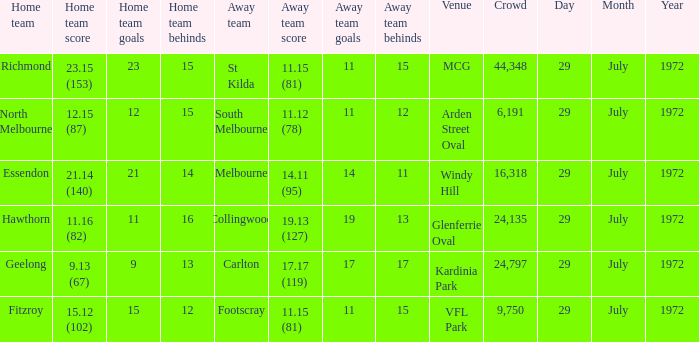When did the away team footscray score 11.15 (81)? 29 July 1972. 